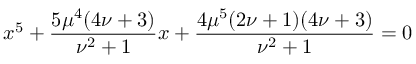<formula> <loc_0><loc_0><loc_500><loc_500>x ^ { 5 } + { \frac { 5 \mu ^ { 4 } ( 4 \nu + 3 ) } { \nu ^ { 2 } + 1 } } x + { \frac { 4 \mu ^ { 5 } ( 2 \nu + 1 ) ( 4 \nu + 3 ) } { \nu ^ { 2 } + 1 } } = 0</formula> 